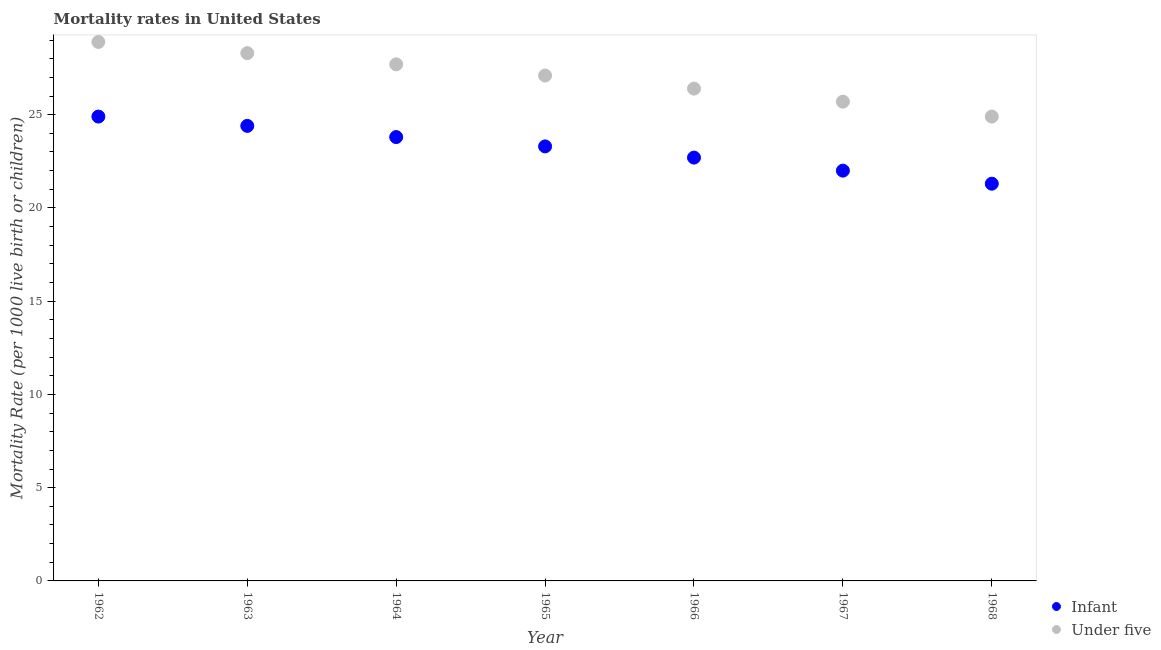How many different coloured dotlines are there?
Offer a very short reply. 2. What is the under-5 mortality rate in 1966?
Your response must be concise. 26.4. Across all years, what is the maximum under-5 mortality rate?
Your answer should be very brief. 28.9. Across all years, what is the minimum under-5 mortality rate?
Offer a terse response. 24.9. In which year was the under-5 mortality rate maximum?
Ensure brevity in your answer.  1962. In which year was the under-5 mortality rate minimum?
Your answer should be compact. 1968. What is the total infant mortality rate in the graph?
Ensure brevity in your answer.  162.4. What is the difference between the under-5 mortality rate in 1964 and that in 1968?
Ensure brevity in your answer.  2.8. What is the difference between the under-5 mortality rate in 1962 and the infant mortality rate in 1965?
Offer a terse response. 5.6. What is the average under-5 mortality rate per year?
Offer a terse response. 27. In the year 1967, what is the difference between the under-5 mortality rate and infant mortality rate?
Offer a terse response. 3.7. In how many years, is the under-5 mortality rate greater than 17?
Offer a terse response. 7. What is the ratio of the infant mortality rate in 1963 to that in 1964?
Provide a short and direct response. 1.03. Is the under-5 mortality rate in 1962 less than that in 1966?
Keep it short and to the point. No. What is the difference between the highest and the lowest infant mortality rate?
Your answer should be compact. 3.6. In how many years, is the infant mortality rate greater than the average infant mortality rate taken over all years?
Ensure brevity in your answer.  4. Does the infant mortality rate monotonically increase over the years?
Offer a terse response. No. Is the under-5 mortality rate strictly greater than the infant mortality rate over the years?
Your answer should be very brief. Yes. How many years are there in the graph?
Give a very brief answer. 7. Are the values on the major ticks of Y-axis written in scientific E-notation?
Provide a short and direct response. No. Does the graph contain grids?
Ensure brevity in your answer.  No. What is the title of the graph?
Provide a short and direct response. Mortality rates in United States. Does "Money lenders" appear as one of the legend labels in the graph?
Provide a succinct answer. No. What is the label or title of the Y-axis?
Offer a terse response. Mortality Rate (per 1000 live birth or children). What is the Mortality Rate (per 1000 live birth or children) of Infant in 1962?
Your answer should be very brief. 24.9. What is the Mortality Rate (per 1000 live birth or children) in Under five in 1962?
Offer a terse response. 28.9. What is the Mortality Rate (per 1000 live birth or children) in Infant in 1963?
Ensure brevity in your answer.  24.4. What is the Mortality Rate (per 1000 live birth or children) of Under five in 1963?
Provide a succinct answer. 28.3. What is the Mortality Rate (per 1000 live birth or children) in Infant in 1964?
Your answer should be very brief. 23.8. What is the Mortality Rate (per 1000 live birth or children) in Under five in 1964?
Ensure brevity in your answer.  27.7. What is the Mortality Rate (per 1000 live birth or children) in Infant in 1965?
Offer a terse response. 23.3. What is the Mortality Rate (per 1000 live birth or children) of Under five in 1965?
Provide a short and direct response. 27.1. What is the Mortality Rate (per 1000 live birth or children) of Infant in 1966?
Keep it short and to the point. 22.7. What is the Mortality Rate (per 1000 live birth or children) of Under five in 1966?
Offer a very short reply. 26.4. What is the Mortality Rate (per 1000 live birth or children) in Infant in 1967?
Ensure brevity in your answer.  22. What is the Mortality Rate (per 1000 live birth or children) of Under five in 1967?
Your answer should be very brief. 25.7. What is the Mortality Rate (per 1000 live birth or children) of Infant in 1968?
Give a very brief answer. 21.3. What is the Mortality Rate (per 1000 live birth or children) in Under five in 1968?
Give a very brief answer. 24.9. Across all years, what is the maximum Mortality Rate (per 1000 live birth or children) of Infant?
Your answer should be very brief. 24.9. Across all years, what is the maximum Mortality Rate (per 1000 live birth or children) of Under five?
Offer a very short reply. 28.9. Across all years, what is the minimum Mortality Rate (per 1000 live birth or children) in Infant?
Keep it short and to the point. 21.3. Across all years, what is the minimum Mortality Rate (per 1000 live birth or children) of Under five?
Your response must be concise. 24.9. What is the total Mortality Rate (per 1000 live birth or children) of Infant in the graph?
Keep it short and to the point. 162.4. What is the total Mortality Rate (per 1000 live birth or children) of Under five in the graph?
Your response must be concise. 189. What is the difference between the Mortality Rate (per 1000 live birth or children) in Infant in 1962 and that in 1963?
Your answer should be compact. 0.5. What is the difference between the Mortality Rate (per 1000 live birth or children) of Infant in 1962 and that in 1964?
Ensure brevity in your answer.  1.1. What is the difference between the Mortality Rate (per 1000 live birth or children) of Infant in 1962 and that in 1965?
Offer a terse response. 1.6. What is the difference between the Mortality Rate (per 1000 live birth or children) of Infant in 1962 and that in 1966?
Provide a short and direct response. 2.2. What is the difference between the Mortality Rate (per 1000 live birth or children) of Under five in 1962 and that in 1967?
Keep it short and to the point. 3.2. What is the difference between the Mortality Rate (per 1000 live birth or children) of Infant in 1963 and that in 1964?
Provide a succinct answer. 0.6. What is the difference between the Mortality Rate (per 1000 live birth or children) in Under five in 1963 and that in 1964?
Make the answer very short. 0.6. What is the difference between the Mortality Rate (per 1000 live birth or children) in Under five in 1963 and that in 1965?
Keep it short and to the point. 1.2. What is the difference between the Mortality Rate (per 1000 live birth or children) in Infant in 1963 and that in 1966?
Your answer should be very brief. 1.7. What is the difference between the Mortality Rate (per 1000 live birth or children) in Under five in 1963 and that in 1966?
Your answer should be compact. 1.9. What is the difference between the Mortality Rate (per 1000 live birth or children) of Under five in 1963 and that in 1967?
Give a very brief answer. 2.6. What is the difference between the Mortality Rate (per 1000 live birth or children) of Infant in 1963 and that in 1968?
Ensure brevity in your answer.  3.1. What is the difference between the Mortality Rate (per 1000 live birth or children) in Infant in 1964 and that in 1968?
Your answer should be compact. 2.5. What is the difference between the Mortality Rate (per 1000 live birth or children) of Under five in 1964 and that in 1968?
Your response must be concise. 2.8. What is the difference between the Mortality Rate (per 1000 live birth or children) in Infant in 1965 and that in 1966?
Offer a terse response. 0.6. What is the difference between the Mortality Rate (per 1000 live birth or children) of Under five in 1965 and that in 1967?
Offer a very short reply. 1.4. What is the difference between the Mortality Rate (per 1000 live birth or children) in Under five in 1966 and that in 1967?
Your answer should be compact. 0.7. What is the difference between the Mortality Rate (per 1000 live birth or children) of Under five in 1966 and that in 1968?
Provide a succinct answer. 1.5. What is the difference between the Mortality Rate (per 1000 live birth or children) of Infant in 1962 and the Mortality Rate (per 1000 live birth or children) of Under five in 1964?
Your answer should be compact. -2.8. What is the difference between the Mortality Rate (per 1000 live birth or children) in Infant in 1962 and the Mortality Rate (per 1000 live birth or children) in Under five in 1965?
Keep it short and to the point. -2.2. What is the difference between the Mortality Rate (per 1000 live birth or children) of Infant in 1962 and the Mortality Rate (per 1000 live birth or children) of Under five in 1966?
Offer a very short reply. -1.5. What is the difference between the Mortality Rate (per 1000 live birth or children) in Infant in 1962 and the Mortality Rate (per 1000 live birth or children) in Under five in 1967?
Keep it short and to the point. -0.8. What is the difference between the Mortality Rate (per 1000 live birth or children) in Infant in 1963 and the Mortality Rate (per 1000 live birth or children) in Under five in 1964?
Your answer should be compact. -3.3. What is the difference between the Mortality Rate (per 1000 live birth or children) in Infant in 1963 and the Mortality Rate (per 1000 live birth or children) in Under five in 1967?
Provide a short and direct response. -1.3. What is the difference between the Mortality Rate (per 1000 live birth or children) of Infant in 1963 and the Mortality Rate (per 1000 live birth or children) of Under five in 1968?
Keep it short and to the point. -0.5. What is the difference between the Mortality Rate (per 1000 live birth or children) in Infant in 1964 and the Mortality Rate (per 1000 live birth or children) in Under five in 1967?
Make the answer very short. -1.9. What is the difference between the Mortality Rate (per 1000 live birth or children) of Infant in 1965 and the Mortality Rate (per 1000 live birth or children) of Under five in 1968?
Provide a succinct answer. -1.6. What is the difference between the Mortality Rate (per 1000 live birth or children) in Infant in 1966 and the Mortality Rate (per 1000 live birth or children) in Under five in 1968?
Give a very brief answer. -2.2. What is the average Mortality Rate (per 1000 live birth or children) in Infant per year?
Offer a very short reply. 23.2. What is the average Mortality Rate (per 1000 live birth or children) of Under five per year?
Offer a very short reply. 27. In the year 1962, what is the difference between the Mortality Rate (per 1000 live birth or children) of Infant and Mortality Rate (per 1000 live birth or children) of Under five?
Provide a succinct answer. -4. In the year 1964, what is the difference between the Mortality Rate (per 1000 live birth or children) of Infant and Mortality Rate (per 1000 live birth or children) of Under five?
Your answer should be very brief. -3.9. In the year 1965, what is the difference between the Mortality Rate (per 1000 live birth or children) in Infant and Mortality Rate (per 1000 live birth or children) in Under five?
Your response must be concise. -3.8. In the year 1967, what is the difference between the Mortality Rate (per 1000 live birth or children) of Infant and Mortality Rate (per 1000 live birth or children) of Under five?
Provide a succinct answer. -3.7. In the year 1968, what is the difference between the Mortality Rate (per 1000 live birth or children) of Infant and Mortality Rate (per 1000 live birth or children) of Under five?
Keep it short and to the point. -3.6. What is the ratio of the Mortality Rate (per 1000 live birth or children) in Infant in 1962 to that in 1963?
Your response must be concise. 1.02. What is the ratio of the Mortality Rate (per 1000 live birth or children) in Under five in 1962 to that in 1963?
Provide a succinct answer. 1.02. What is the ratio of the Mortality Rate (per 1000 live birth or children) in Infant in 1962 to that in 1964?
Give a very brief answer. 1.05. What is the ratio of the Mortality Rate (per 1000 live birth or children) in Under five in 1962 to that in 1964?
Your answer should be very brief. 1.04. What is the ratio of the Mortality Rate (per 1000 live birth or children) of Infant in 1962 to that in 1965?
Give a very brief answer. 1.07. What is the ratio of the Mortality Rate (per 1000 live birth or children) of Under five in 1962 to that in 1965?
Provide a short and direct response. 1.07. What is the ratio of the Mortality Rate (per 1000 live birth or children) in Infant in 1962 to that in 1966?
Ensure brevity in your answer.  1.1. What is the ratio of the Mortality Rate (per 1000 live birth or children) in Under five in 1962 to that in 1966?
Offer a terse response. 1.09. What is the ratio of the Mortality Rate (per 1000 live birth or children) of Infant in 1962 to that in 1967?
Provide a succinct answer. 1.13. What is the ratio of the Mortality Rate (per 1000 live birth or children) of Under five in 1962 to that in 1967?
Your answer should be compact. 1.12. What is the ratio of the Mortality Rate (per 1000 live birth or children) in Infant in 1962 to that in 1968?
Provide a succinct answer. 1.17. What is the ratio of the Mortality Rate (per 1000 live birth or children) in Under five in 1962 to that in 1968?
Provide a succinct answer. 1.16. What is the ratio of the Mortality Rate (per 1000 live birth or children) in Infant in 1963 to that in 1964?
Offer a very short reply. 1.03. What is the ratio of the Mortality Rate (per 1000 live birth or children) of Under five in 1963 to that in 1964?
Provide a succinct answer. 1.02. What is the ratio of the Mortality Rate (per 1000 live birth or children) in Infant in 1963 to that in 1965?
Give a very brief answer. 1.05. What is the ratio of the Mortality Rate (per 1000 live birth or children) in Under five in 1963 to that in 1965?
Provide a succinct answer. 1.04. What is the ratio of the Mortality Rate (per 1000 live birth or children) of Infant in 1963 to that in 1966?
Your response must be concise. 1.07. What is the ratio of the Mortality Rate (per 1000 live birth or children) in Under five in 1963 to that in 1966?
Give a very brief answer. 1.07. What is the ratio of the Mortality Rate (per 1000 live birth or children) of Infant in 1963 to that in 1967?
Provide a succinct answer. 1.11. What is the ratio of the Mortality Rate (per 1000 live birth or children) of Under five in 1963 to that in 1967?
Make the answer very short. 1.1. What is the ratio of the Mortality Rate (per 1000 live birth or children) in Infant in 1963 to that in 1968?
Give a very brief answer. 1.15. What is the ratio of the Mortality Rate (per 1000 live birth or children) of Under five in 1963 to that in 1968?
Provide a succinct answer. 1.14. What is the ratio of the Mortality Rate (per 1000 live birth or children) of Infant in 1964 to that in 1965?
Offer a terse response. 1.02. What is the ratio of the Mortality Rate (per 1000 live birth or children) in Under five in 1964 to that in 1965?
Provide a succinct answer. 1.02. What is the ratio of the Mortality Rate (per 1000 live birth or children) of Infant in 1964 to that in 1966?
Provide a succinct answer. 1.05. What is the ratio of the Mortality Rate (per 1000 live birth or children) of Under five in 1964 to that in 1966?
Give a very brief answer. 1.05. What is the ratio of the Mortality Rate (per 1000 live birth or children) of Infant in 1964 to that in 1967?
Ensure brevity in your answer.  1.08. What is the ratio of the Mortality Rate (per 1000 live birth or children) in Under five in 1964 to that in 1967?
Ensure brevity in your answer.  1.08. What is the ratio of the Mortality Rate (per 1000 live birth or children) in Infant in 1964 to that in 1968?
Provide a short and direct response. 1.12. What is the ratio of the Mortality Rate (per 1000 live birth or children) of Under five in 1964 to that in 1968?
Offer a very short reply. 1.11. What is the ratio of the Mortality Rate (per 1000 live birth or children) of Infant in 1965 to that in 1966?
Your answer should be compact. 1.03. What is the ratio of the Mortality Rate (per 1000 live birth or children) of Under five in 1965 to that in 1966?
Offer a very short reply. 1.03. What is the ratio of the Mortality Rate (per 1000 live birth or children) of Infant in 1965 to that in 1967?
Offer a terse response. 1.06. What is the ratio of the Mortality Rate (per 1000 live birth or children) of Under five in 1965 to that in 1967?
Keep it short and to the point. 1.05. What is the ratio of the Mortality Rate (per 1000 live birth or children) in Infant in 1965 to that in 1968?
Offer a terse response. 1.09. What is the ratio of the Mortality Rate (per 1000 live birth or children) of Under five in 1965 to that in 1968?
Offer a terse response. 1.09. What is the ratio of the Mortality Rate (per 1000 live birth or children) of Infant in 1966 to that in 1967?
Keep it short and to the point. 1.03. What is the ratio of the Mortality Rate (per 1000 live birth or children) of Under five in 1966 to that in 1967?
Provide a succinct answer. 1.03. What is the ratio of the Mortality Rate (per 1000 live birth or children) of Infant in 1966 to that in 1968?
Provide a short and direct response. 1.07. What is the ratio of the Mortality Rate (per 1000 live birth or children) of Under five in 1966 to that in 1968?
Give a very brief answer. 1.06. What is the ratio of the Mortality Rate (per 1000 live birth or children) of Infant in 1967 to that in 1968?
Make the answer very short. 1.03. What is the ratio of the Mortality Rate (per 1000 live birth or children) of Under five in 1967 to that in 1968?
Your response must be concise. 1.03. What is the difference between the highest and the second highest Mortality Rate (per 1000 live birth or children) of Infant?
Provide a short and direct response. 0.5. What is the difference between the highest and the lowest Mortality Rate (per 1000 live birth or children) in Infant?
Make the answer very short. 3.6. 